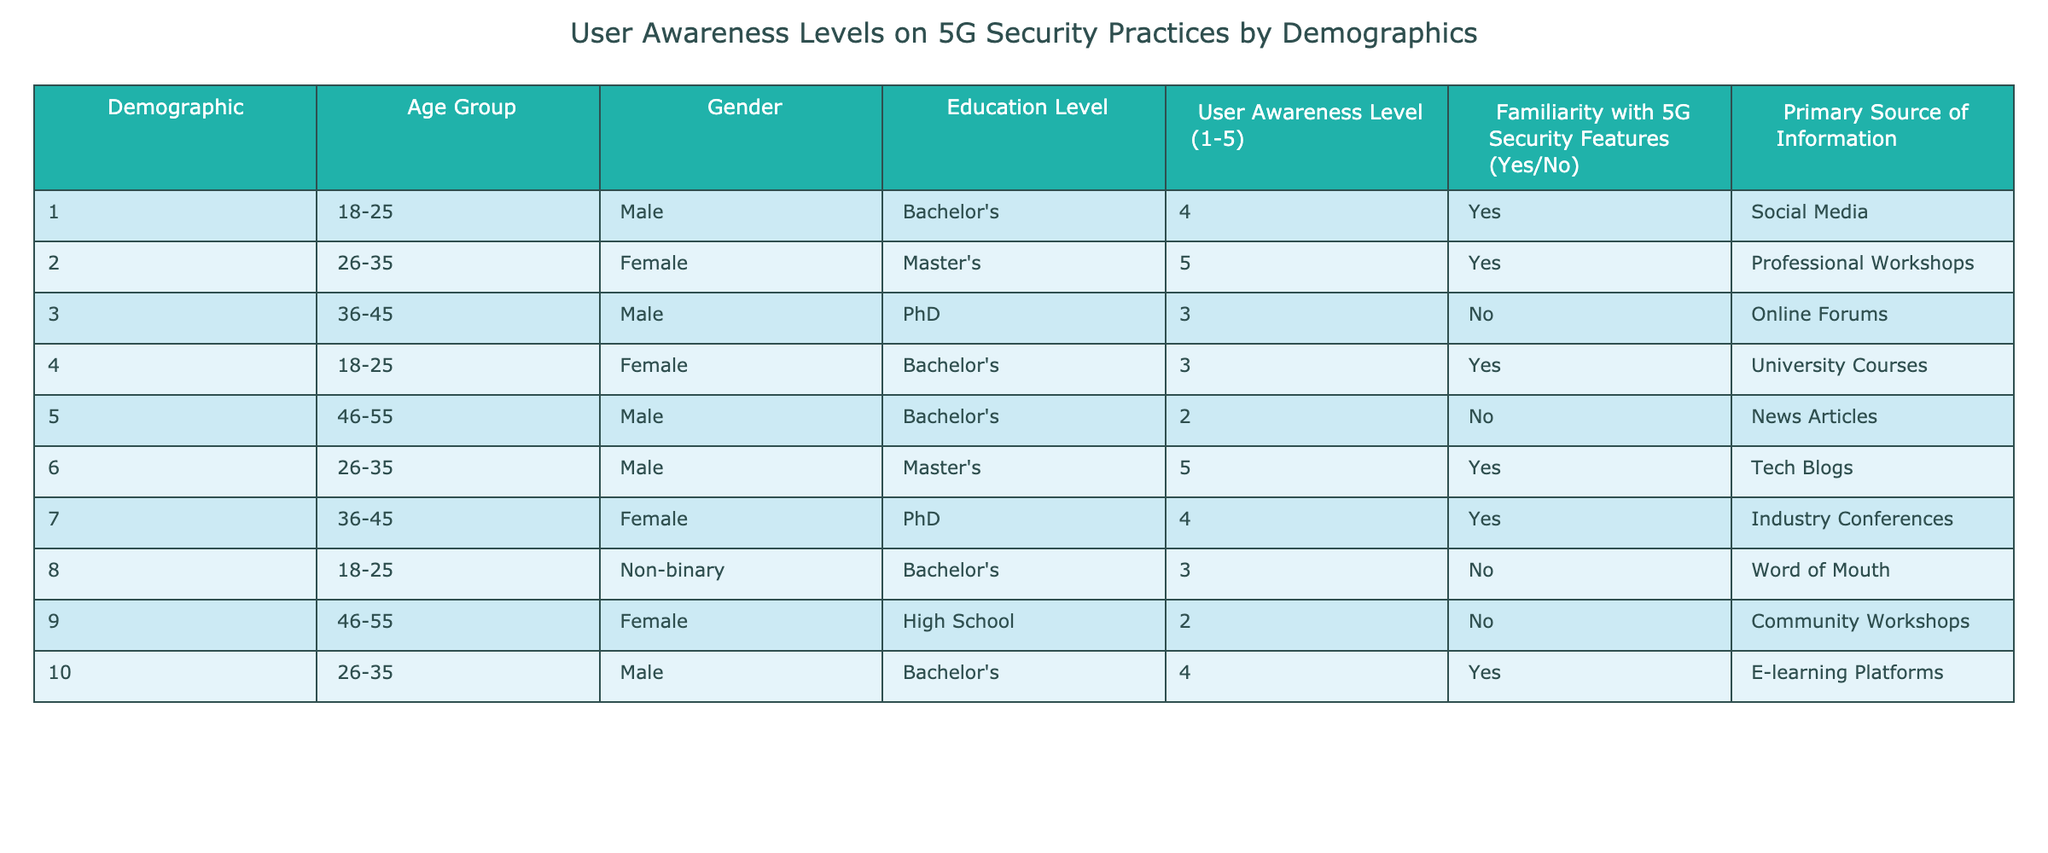What is the user awareness level of the youngest age group? The youngest age group is 18-25. There are three individuals in this age group. Their awareness levels are 4, 3, and 3. The highest awareness level is 4, so the answer is 4.
Answer: 4 How many males have a user awareness level of 5? There are two males in the data set with a user awareness level of 5: one is in the age group of 26-35 and the other is in the age group's 26-35 and holds a Master's degree.
Answer: 2 What is the average user awareness level for individuals with a Master's degree? There are two individuals with a Master's degree: one in the age group of 26-35 with a level of 5, and another also in the age group of 26-35 with a level of 5. The sum of their levels is 5 + 5 = 10. The average is 10/2 = 5.
Answer: 5 Is there anyone with a user awareness level of 2 among the 46-55 age group? There are two individuals in the 46-55 age group, one male with a user awareness level of 2 and one female with a user awareness level of 2. Since both have levels of 2, the answer is yes.
Answer: Yes What is the total number of individuals who are familiar with 5G security features? There are six individuals who have responded 'Yes' to the familiarity with 5G security features: one in age 18-25, two aged 26-35, two aged 36-45, and one aged 18-25. Adding these, we get a total of 6 individuals.
Answer: 6 How many females in the data have a user awareness level higher than 3? There are two females with a user awareness level higher than 3: one 26-35 with a level of 5 and one 36-45 with a level of 4. So, we count them to get two.
Answer: 2 Which demographic has the lowest mean awareness level overall? First, we calculate the mean awareness levels for each demographic group: males (2.5), females (3.4), non-binary (3.0). The lowest mean is for males at 2.5.
Answer: Males Is there anyone who reported "Community Workshops" as their primary source of information? Yes, one individual in the 46-55 age group, who is a female, has "Community Workshops" listed as her primary source of information.
Answer: Yes 